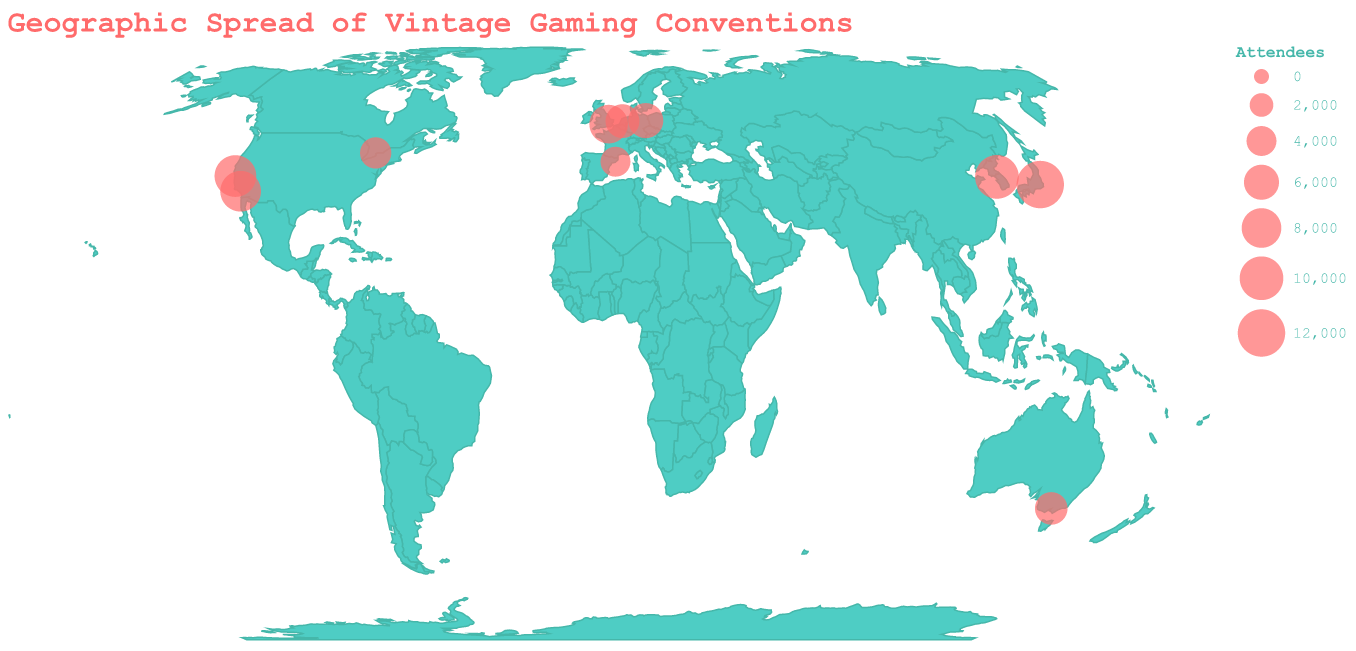What is the title of the plot? The title of the plot is prominently displayed at the top and uses a unique font. It states "Geographic Spread of Vintage Gaming Conventions".
Answer: Geographic Spread of Vintage Gaming Conventions Which convention has the highest number of attendees, and where is it located? By looking at the size of the circles on the map and referring to the tooltip, the largest circle size indicates the highest number of attendees. The biggest circle corresponds to "Retro Game Expo" in Tokyo, Japan, with 12,000 attendees.
Answer: Retro Game Expo in Tokyo, Japan Which continents have the most vintage gaming conventions according to the plot? Several conventions are plotted across the map. By visually analyzing the geographic distribution, most conventions are in North America, Europe, and Asia.
Answer: North America, Europe, Asia How many conventions are there in the USA according to the plot? Observing the geographic points in the USA and referring to tooltips, there are two conventions: PixelCon in Los Angeles and VFX & Retro Games Summit in San Francisco.
Answer: 2 Which convention has fewer attendees, Retrobarcelona or European Retro Gaming Fair? By comparing the size of the circles for Retrobarcelona and European Retro Gaming Fair on the map and referring to the attendee count in the tooltips, Retrobarcelona has 4,000 attendees while European Retro Gaming Fair has 5,500 attendees.
Answer: Retrobarcelona What is the average number of attendees for all conventions? To find the average, first sum up all attendees: 12,000 (Tokyo) + 8,500 (Los Angeles) + 6,000 (Berlin) + 7,500 (London) + 5,000 (Melbourne) + 9,000 (San Francisco) + 4,500 (Toronto) + 10,000 (Seoul) + 5,500 (Amsterdam) + 4,000 (Barcelona) = 72,000. There are 10 conventions, so average = 72,000 / 10 = 7,200 attendees.
Answer: 7,200 attendees Which city has a convention with fewer than 5,000 attendees? Examine the tooltips to identify which conventions have fewer than 5,000 attendees. Toronto's Pixel Art Con has 4,500 attendees, and Barcelona's Retrobarcelona has 4,000 attendees.
Answer: Toronto and Barcelona Which convention has the second-highest number of attendees? By comparing the size of the circles and referring to the tooltips, Seoul's Classic Gaming Korea has the second-highest number of attendees with 10,000, after Tokyo’s Retro Game Expo with 12,000 attendees.
Answer: Classic Gaming Korea in Seoul If you combine the attendee counts for the conventions in the USA, what is the total? The USA has two conventions: PixelCon in Los Angeles with 8,500 attendees and VFX & Retro Games Summit in San Francisco with 9,000 attendees. The total number of attendees = 8,500 + 9,000 = 17,500.
Answer: 17,500 